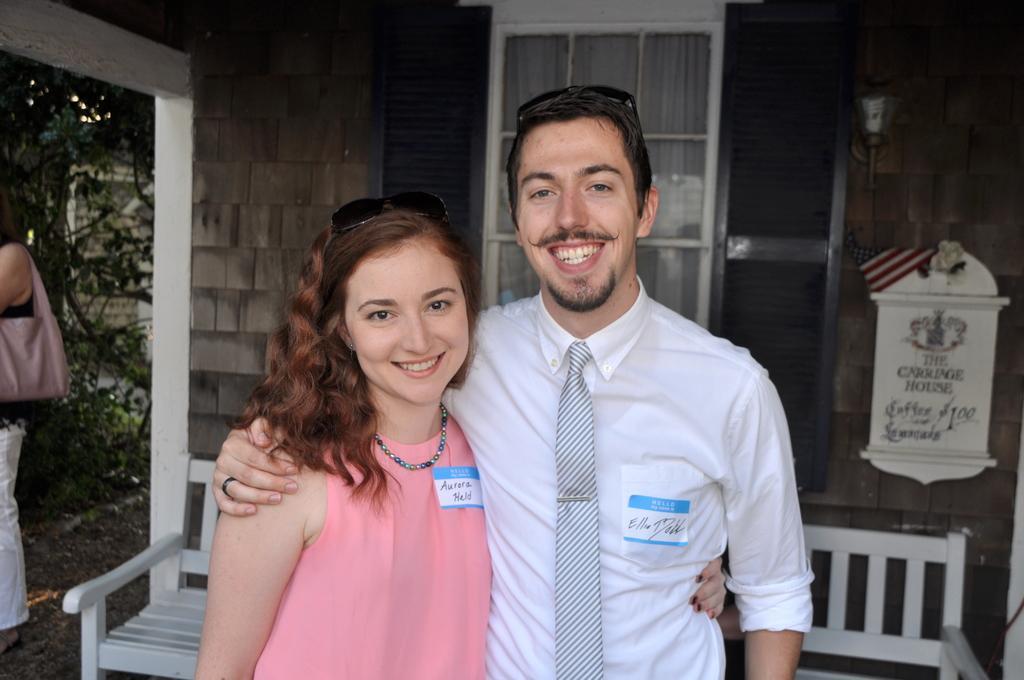How would you summarize this image in a sentence or two? In the middle of the image there is a lady with pink dress is standing and there is a chain around her neck. And also there are goggles on her head. Beside her there is a man with white shirt and tie is standing and there are goggles on his head. Behind them there is a white bench. Behind the bench there's a wall with window and lamp. And to the left corner of the image there is a lady with bag and behind her there are trees. 